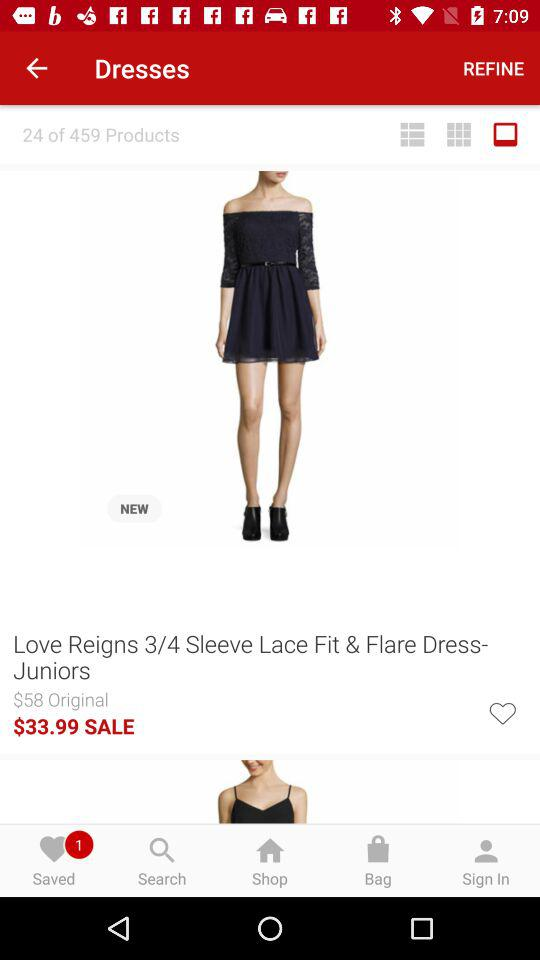How much is the dress on sale for?
Answer the question using a single word or phrase. $33.99 